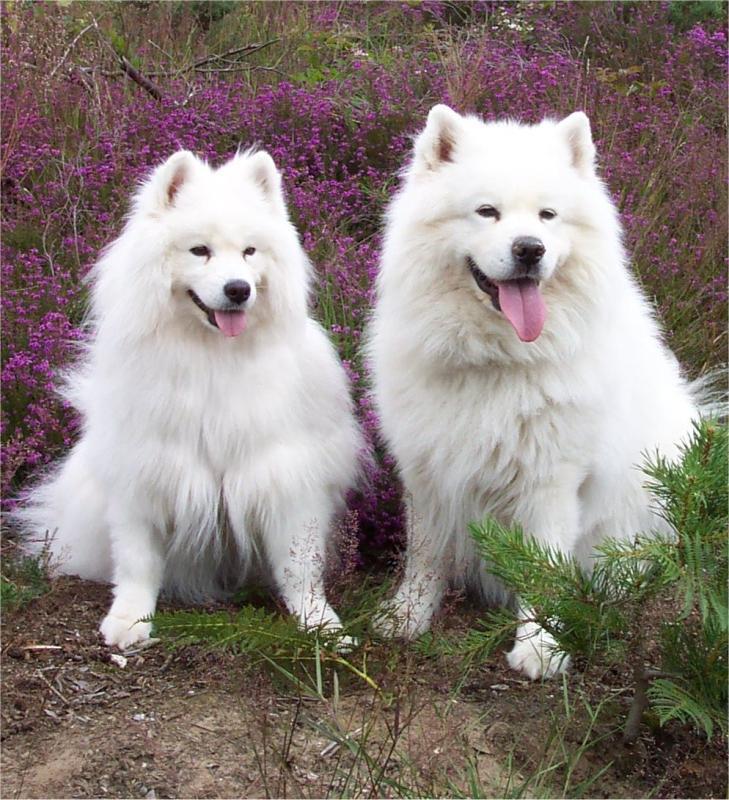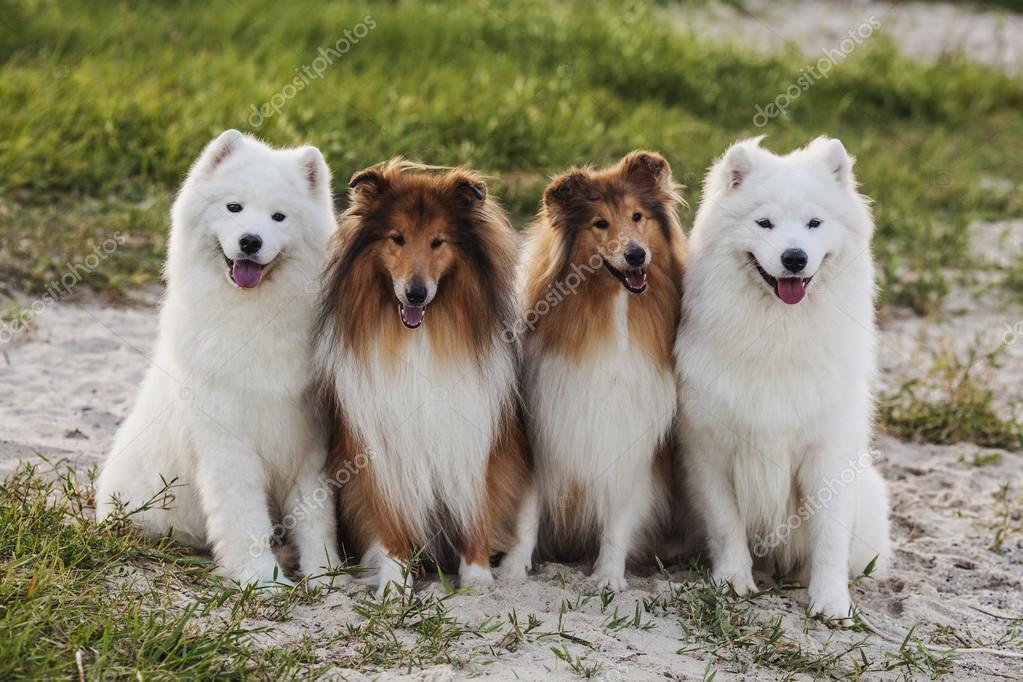The first image is the image on the left, the second image is the image on the right. Considering the images on both sides, is "One image shows two white dogs sitting upright side-by-side, and the other image shows two sitting collies flanked by two sitting white dogs." valid? Answer yes or no. Yes. The first image is the image on the left, the second image is the image on the right. Given the left and right images, does the statement "One of the images has two brown and white dogs in between two white dogs." hold true? Answer yes or no. Yes. 